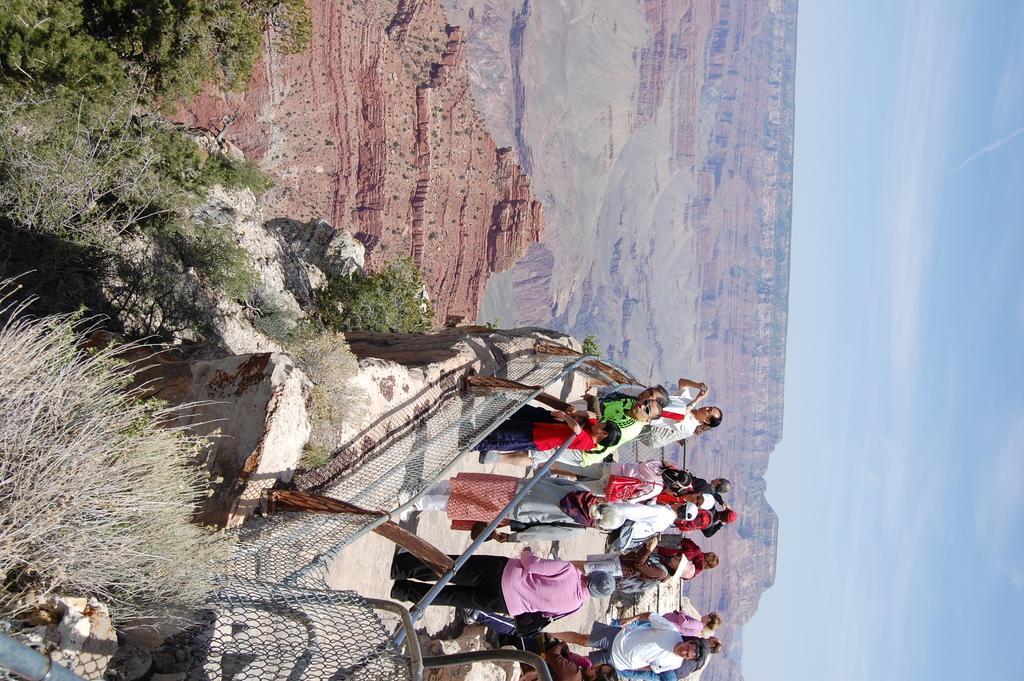How would you summarize this image in a sentence or two? There are few persons standing and there are trees and a fence in front of them and there are mountains in the background. 